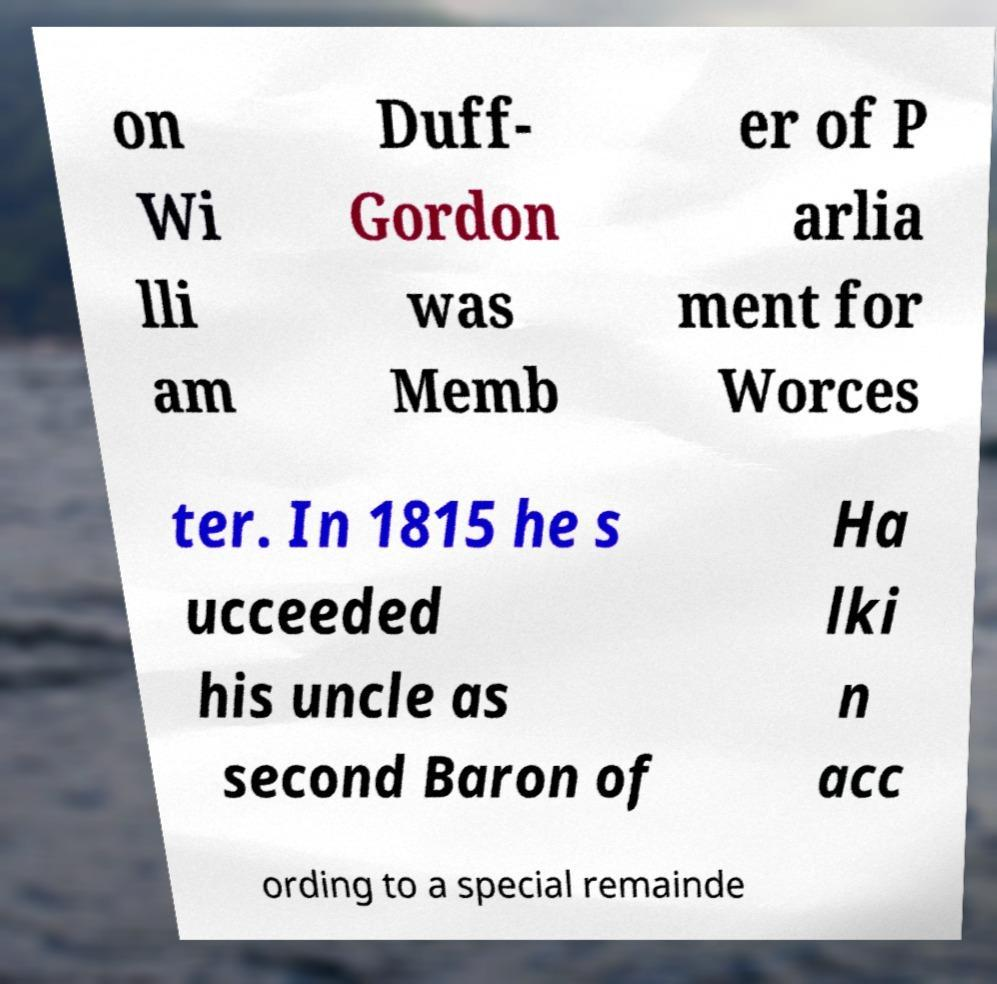Please read and relay the text visible in this image. What does it say? on Wi lli am Duff- Gordon was Memb er of P arlia ment for Worces ter. In 1815 he s ucceeded his uncle as second Baron of Ha lki n acc ording to a special remainde 